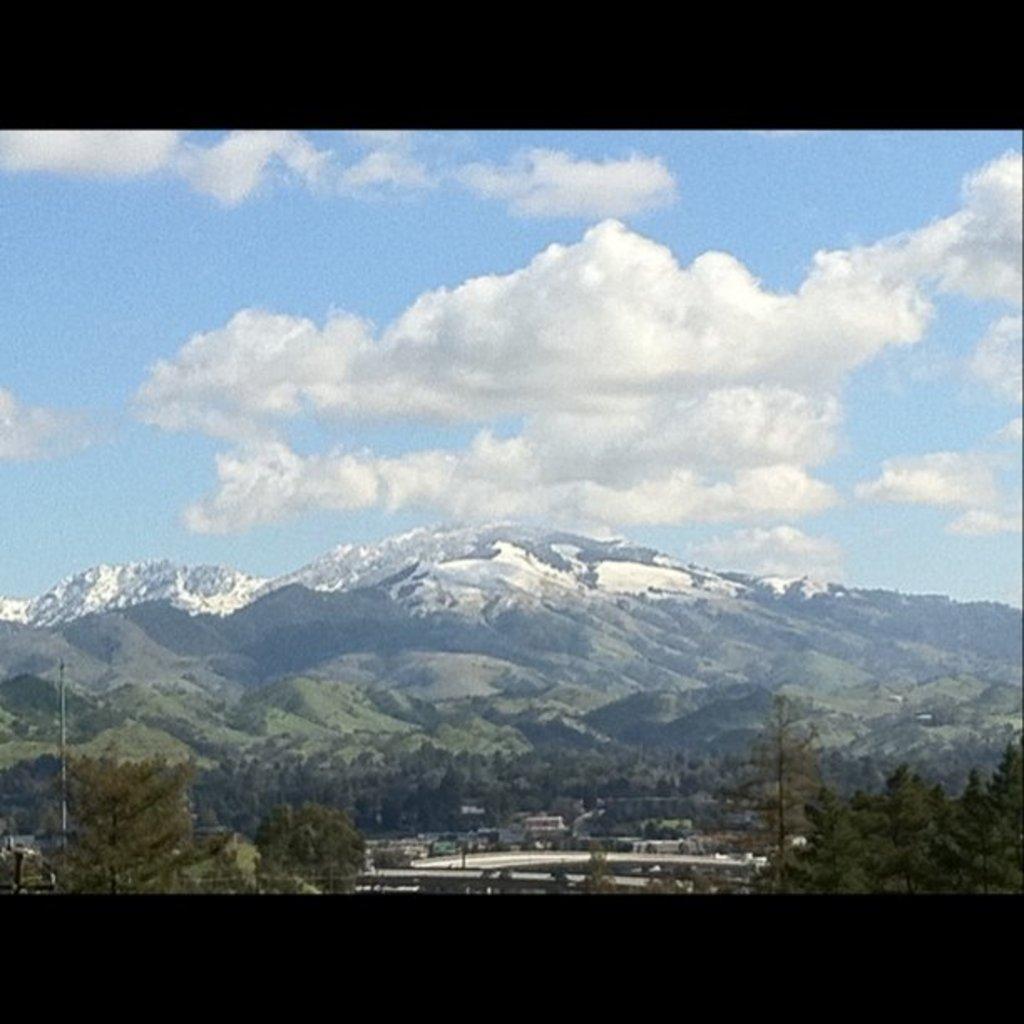Could you give a brief overview of what you see in this image? In this picture, we can see a pole, trees, hills, some items and a cloudy sky. 